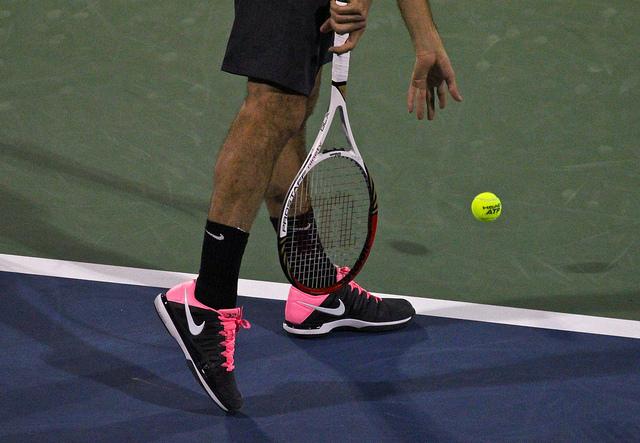What brand are the shoes?
Be succinct. Nike. What colors are the shoes?
Answer briefly. Black and pink. Is this a male or female tennis player?
Short answer required. Male. 